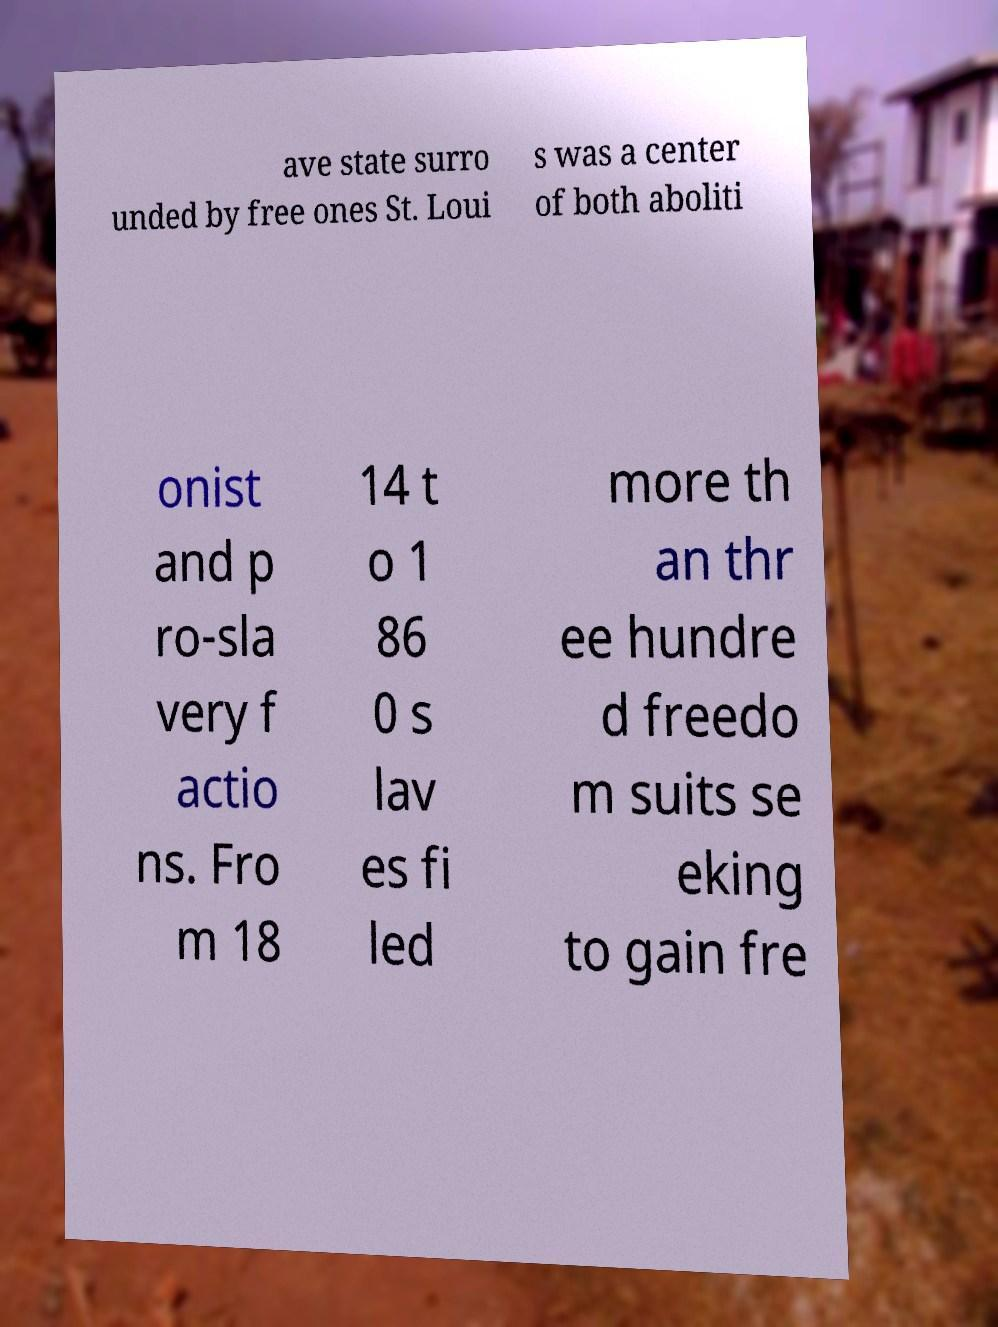Could you assist in decoding the text presented in this image and type it out clearly? ave state surro unded by free ones St. Loui s was a center of both aboliti onist and p ro-sla very f actio ns. Fro m 18 14 t o 1 86 0 s lav es fi led more th an thr ee hundre d freedo m suits se eking to gain fre 